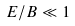Convert formula to latex. <formula><loc_0><loc_0><loc_500><loc_500>E / B \ll 1</formula> 